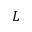<formula> <loc_0><loc_0><loc_500><loc_500>L</formula> 